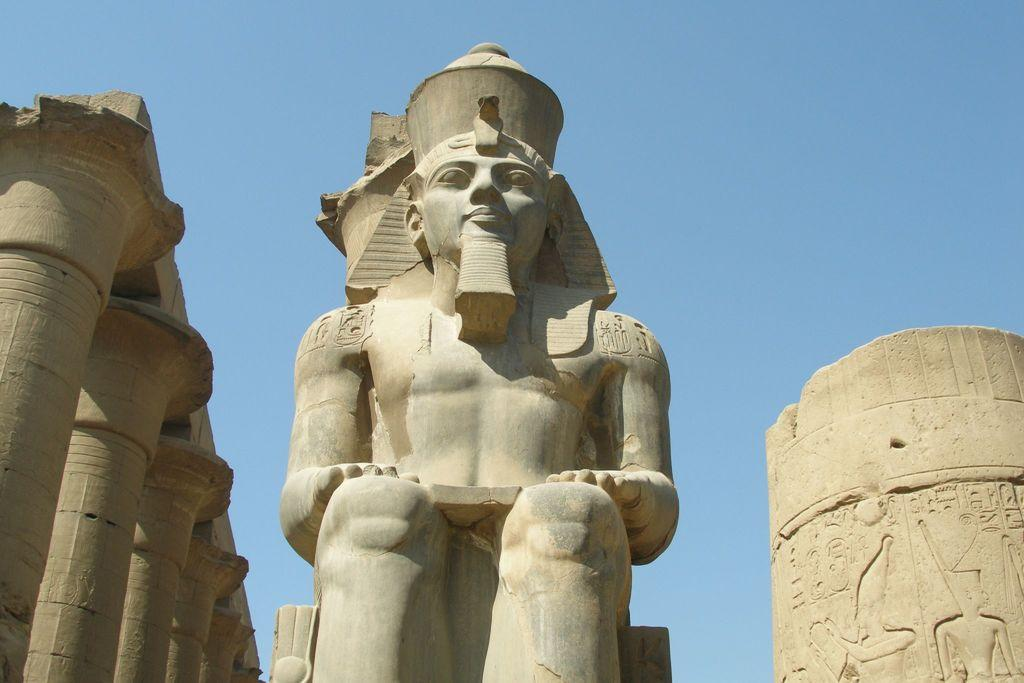What type of statue can be seen in the image? There is an Egyptian statue in the image. What architectural features are present in the image? There are pillars in the image. What material is the design carved on in the image? The design is carved on stone in the image. What can be seen in the background of the image? The sky is visible in the image. Can you tell me how many times the statue has been copied in the image? There is no indication in the image that the statue has been copied, as it is a single statue. Is there a bath visible in the image? There is no bath present in the image. 